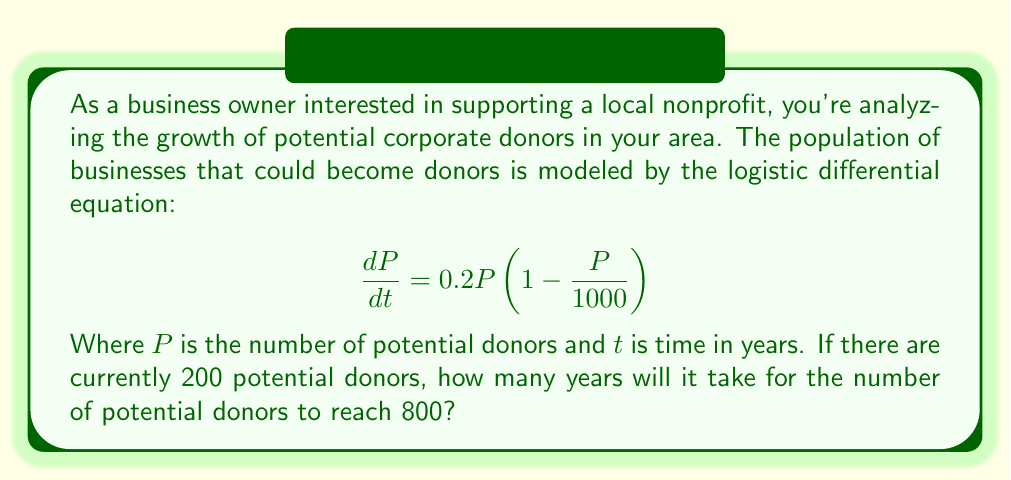Can you answer this question? To solve this problem, we'll use the logistic growth model and its solution. The steps are as follows:

1) The general solution to the logistic differential equation is:

   $$P(t) = \frac{K}{1 + Ce^{-rt}}$$

   Where $K$ is the carrying capacity, $r$ is the growth rate, and $C$ is a constant.

2) From the given equation, we can identify:
   $K = 1000$ (carrying capacity)
   $r = 0.2$ (growth rate)

3) We need to find $C$ using the initial condition $P(0) = 200$:

   $$200 = \frac{1000}{1 + C}$$
   $$C = 4$$

4) Now our specific solution is:

   $$P(t) = \frac{1000}{1 + 4e^{-0.2t}}$$

5) We want to find $t$ when $P(t) = 800$:

   $$800 = \frac{1000}{1 + 4e^{-0.2t}}$$

6) Solving for $t$:

   $$1 + 4e^{-0.2t} = \frac{1000}{800} = 1.25$$
   $$4e^{-0.2t} = 0.25$$
   $$e^{-0.2t} = 0.0625$$
   $$-0.2t = \ln(0.0625) = -2.7726$$
   $$t = 13.863$$

7) Therefore, it will take approximately 13.86 years for the number of potential donors to reach 800.
Answer: 13.86 years 